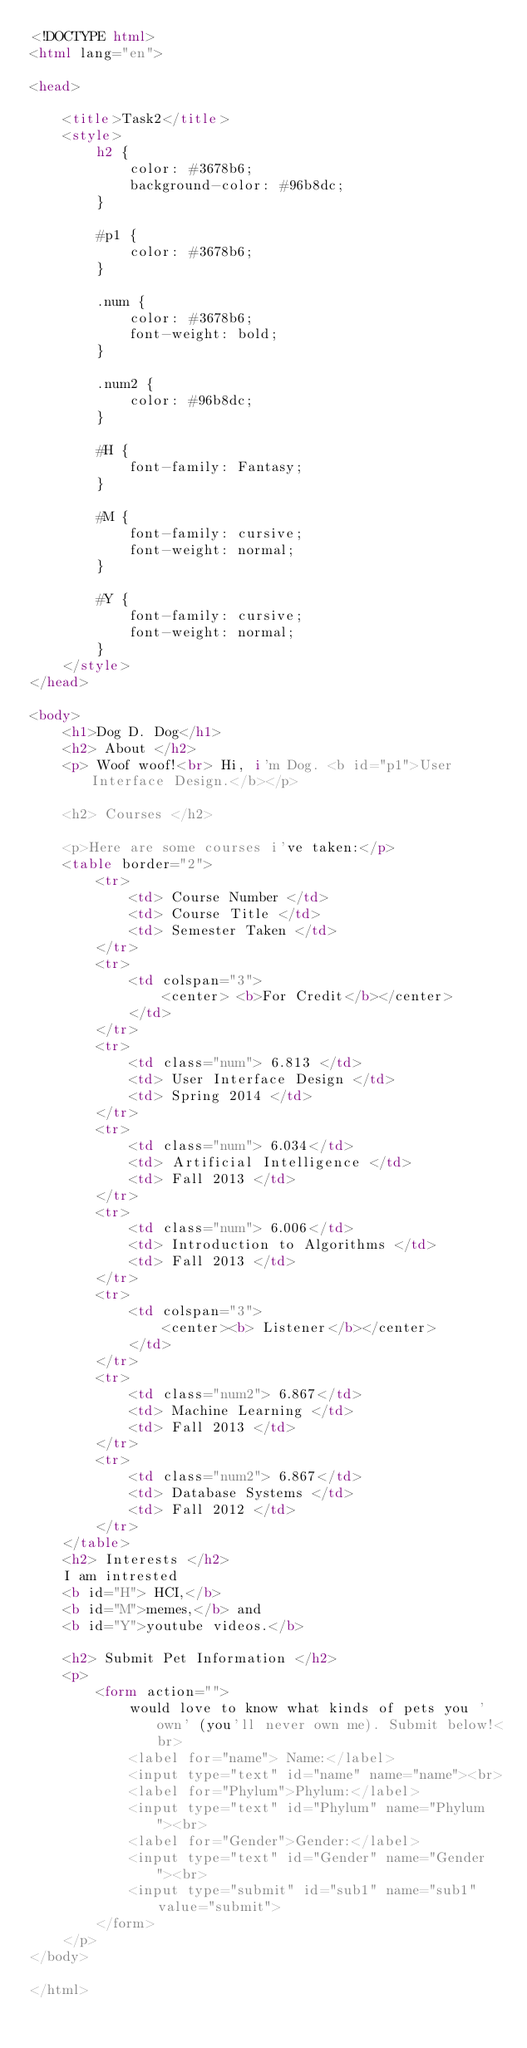<code> <loc_0><loc_0><loc_500><loc_500><_HTML_><!DOCTYPE html>
<html lang="en">

<head>

    <title>Task2</title>
    <style>
        h2 {
            color: #3678b6;
            background-color: #96b8dc;
        }
        
        #p1 {
            color: #3678b6;
        }
        
        .num {
            color: #3678b6;
            font-weight: bold;
        }
        
        .num2 {
            color: #96b8dc;
        }
        
        #H {
            font-family: Fantasy;
        }
        
        #M {
            font-family: cursive;
            font-weight: normal;
        }
        
        #Y {
            font-family: cursive;
            font-weight: normal;
        }
    </style>
</head>

<body>
    <h1>Dog D. Dog</h1>
    <h2> About </h2>
    <p> Woof woof!<br> Hi, i'm Dog. <b id="p1">User Interface Design.</b></p>

    <h2> Courses </h2>

    <p>Here are some courses i've taken:</p>
    <table border="2">
        <tr>
            <td> Course Number </td>
            <td> Course Title </td>
            <td> Semester Taken </td>
        </tr>
        <tr>
            <td colspan="3">
                <center> <b>For Credit</b></center>
            </td>
        </tr>
        <tr>
            <td class="num"> 6.813 </td>
            <td> User Interface Design </td>
            <td> Spring 2014 </td>
        </tr>
        <tr>
            <td class="num"> 6.034</td>
            <td> Artificial Intelligence </td>
            <td> Fall 2013 </td>
        </tr>
        <tr>
            <td class="num"> 6.006</td>
            <td> Introduction to Algorithms </td>
            <td> Fall 2013 </td>
        </tr>
        <tr>
            <td colspan="3">
                <center><b> Listener</b></center>
            </td>
        </tr>
        <tr>
            <td class="num2"> 6.867</td>
            <td> Machine Learning </td>
            <td> Fall 2013 </td>
        </tr>
        <tr>
            <td class="num2"> 6.867</td>
            <td> Database Systems </td>
            <td> Fall 2012 </td>
        </tr>
    </table>
    <h2> Interests </h2>
    I am intrested
    <b id="H"> HCI,</b>
    <b id="M">memes,</b> and
    <b id="Y">youtube videos.</b>

    <h2> Submit Pet Information </h2>
    <p>
        <form action="">
            would love to know what kinds of pets you 'own' (you'll never own me). Submit below!<br>
            <label for="name"> Name:</label>
            <input type="text" id="name" name="name"><br>
            <label for="Phylum">Phylum:</label>
            <input type="text" id="Phylum" name="Phylum"><br>
            <label for="Gender">Gender:</label>
            <input type="text" id="Gender" name="Gender"><br>
            <input type="submit" id="sub1" name="sub1" value="submit">
        </form>
    </p>
</body>

</html></code> 